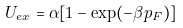Convert formula to latex. <formula><loc_0><loc_0><loc_500><loc_500>U _ { e x } = \alpha [ 1 - \exp ( - \beta p _ { F } ) ]</formula> 